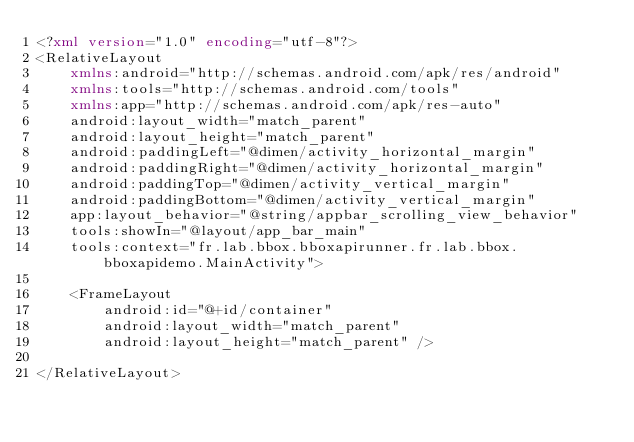<code> <loc_0><loc_0><loc_500><loc_500><_XML_><?xml version="1.0" encoding="utf-8"?>
<RelativeLayout
    xmlns:android="http://schemas.android.com/apk/res/android"
    xmlns:tools="http://schemas.android.com/tools"
    xmlns:app="http://schemas.android.com/apk/res-auto"
    android:layout_width="match_parent"
    android:layout_height="match_parent"
    android:paddingLeft="@dimen/activity_horizontal_margin"
    android:paddingRight="@dimen/activity_horizontal_margin"
    android:paddingTop="@dimen/activity_vertical_margin"
    android:paddingBottom="@dimen/activity_vertical_margin"
    app:layout_behavior="@string/appbar_scrolling_view_behavior"
    tools:showIn="@layout/app_bar_main"
    tools:context="fr.lab.bbox.bboxapirunner.fr.lab.bbox.bboxapidemo.MainActivity">

    <FrameLayout
        android:id="@+id/container"
        android:layout_width="match_parent"
        android:layout_height="match_parent" />

</RelativeLayout>
</code> 